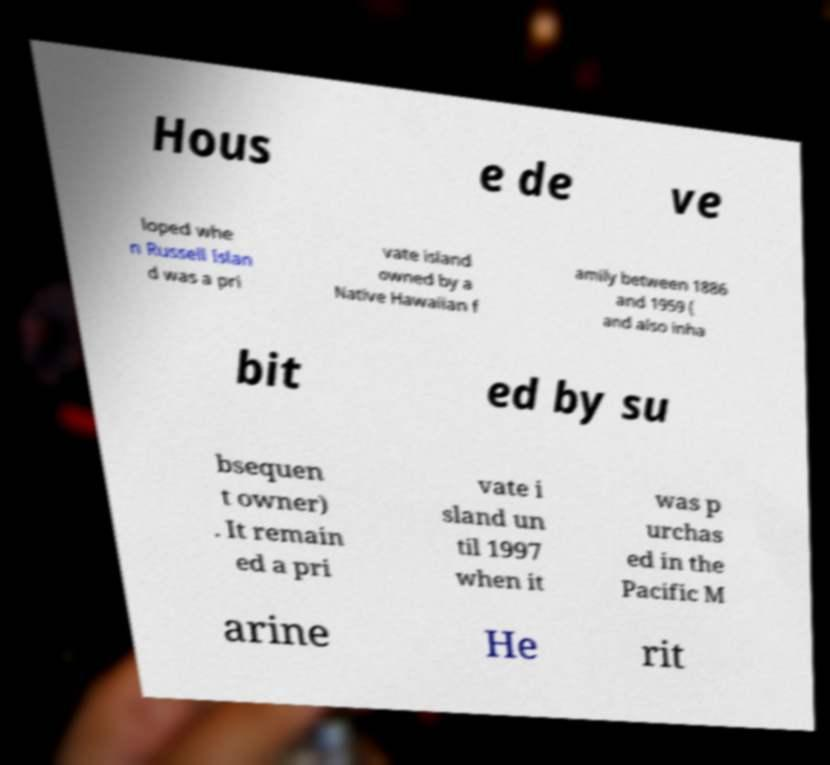Could you extract and type out the text from this image? Hous e de ve loped whe n Russell Islan d was a pri vate island owned by a Native Hawaiian f amily between 1886 and 1959 ( and also inha bit ed by su bsequen t owner) . It remain ed a pri vate i sland un til 1997 when it was p urchas ed in the Pacific M arine He rit 